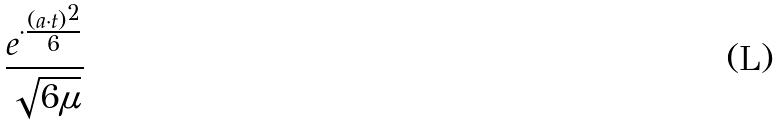<formula> <loc_0><loc_0><loc_500><loc_500>\frac { e ^ { \cdot \frac { ( a \cdot t ) ^ { 2 } } { 6 } } } { \sqrt { 6 \mu } }</formula> 